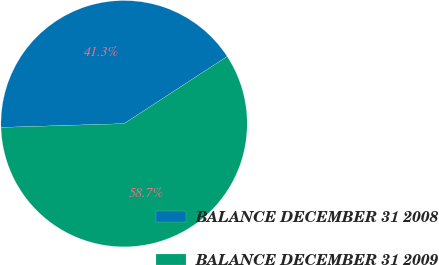Convert chart to OTSL. <chart><loc_0><loc_0><loc_500><loc_500><pie_chart><fcel>BALANCE DECEMBER 31 2008<fcel>BALANCE DECEMBER 31 2009<nl><fcel>41.3%<fcel>58.7%<nl></chart> 